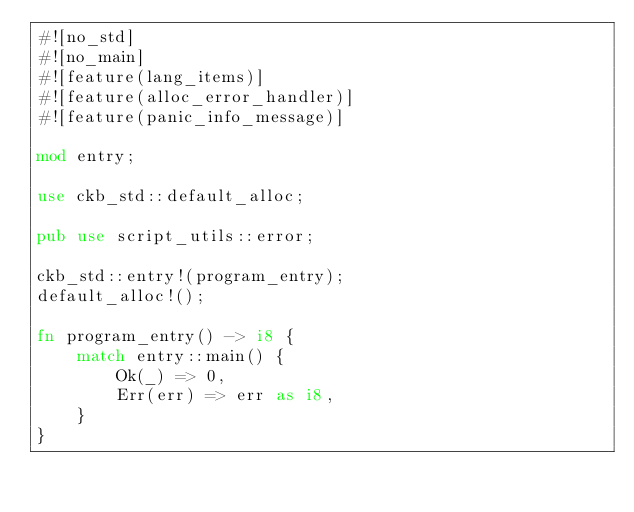Convert code to text. <code><loc_0><loc_0><loc_500><loc_500><_Rust_>#![no_std]
#![no_main]
#![feature(lang_items)]
#![feature(alloc_error_handler)]
#![feature(panic_info_message)]

mod entry;

use ckb_std::default_alloc;

pub use script_utils::error;

ckb_std::entry!(program_entry);
default_alloc!();

fn program_entry() -> i8 {
    match entry::main() {
        Ok(_) => 0,
        Err(err) => err as i8,
    }
}
</code> 